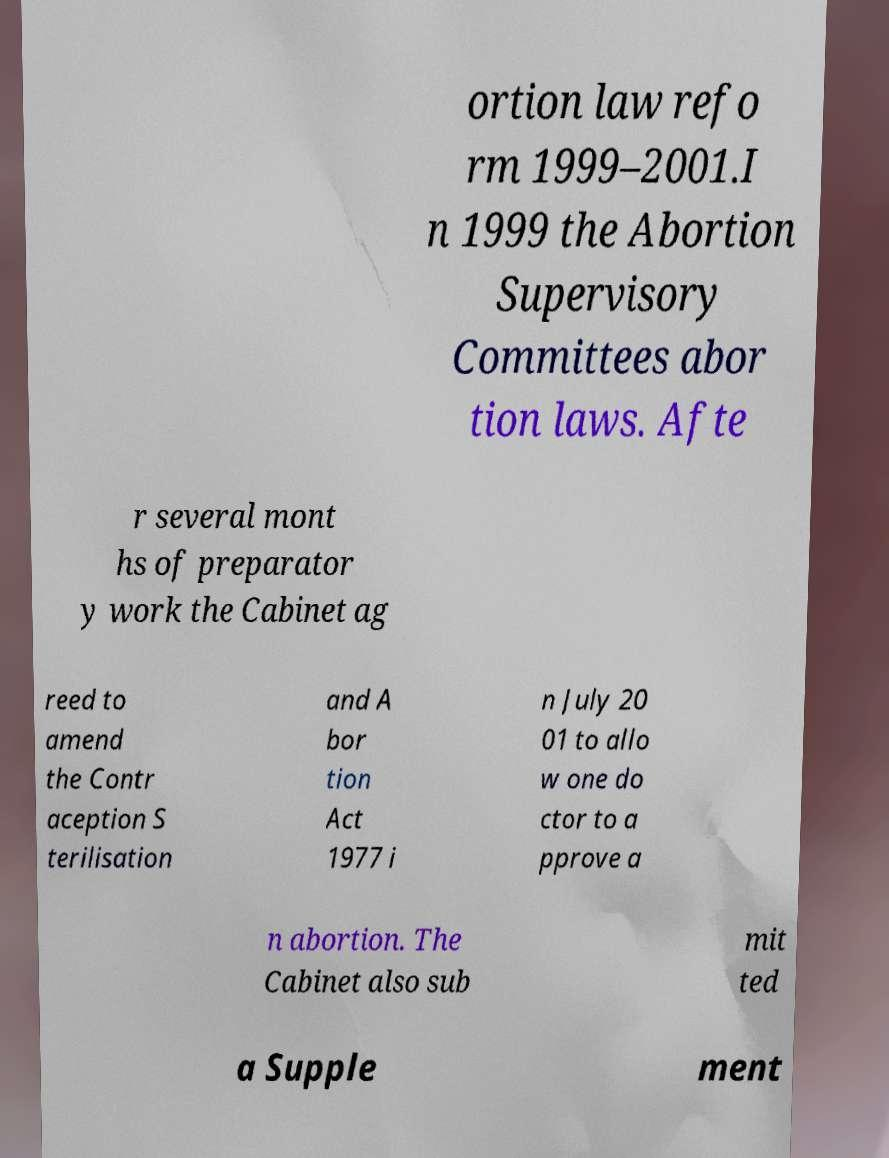Please identify and transcribe the text found in this image. ortion law refo rm 1999–2001.I n 1999 the Abortion Supervisory Committees abor tion laws. Afte r several mont hs of preparator y work the Cabinet ag reed to amend the Contr aception S terilisation and A bor tion Act 1977 i n July 20 01 to allo w one do ctor to a pprove a n abortion. The Cabinet also sub mit ted a Supple ment 